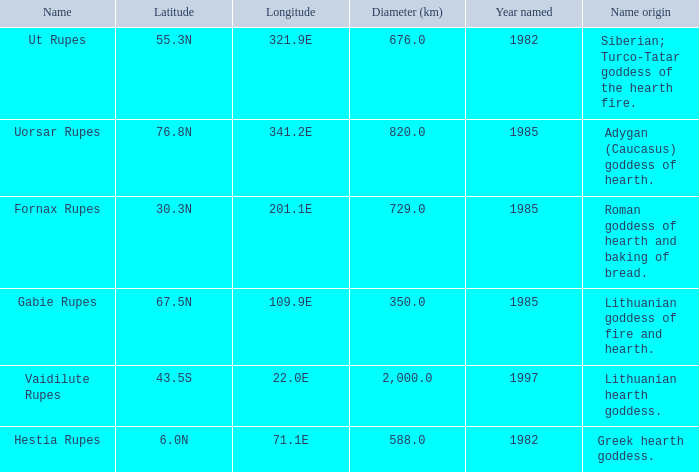At a latitude of 71.1e, what is the feature's name origin? Greek hearth goddess. 